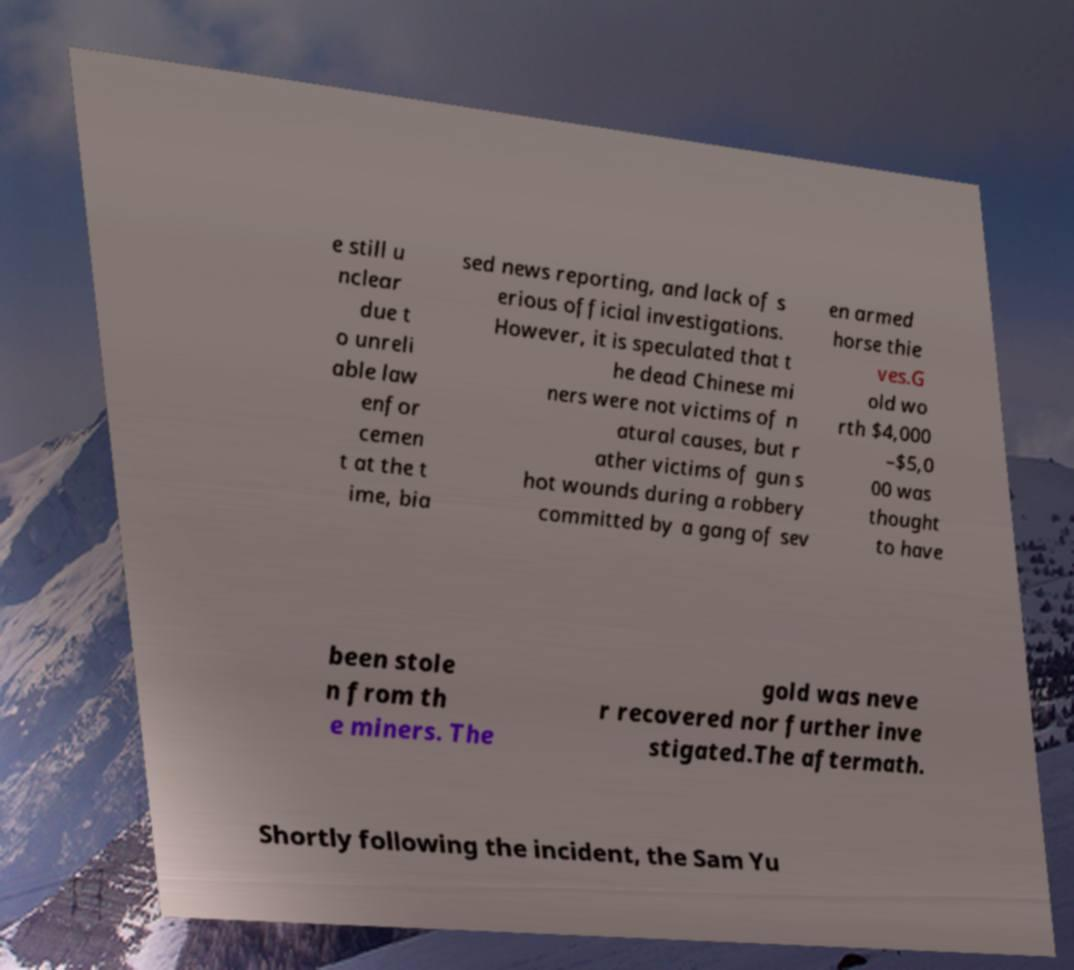Please read and relay the text visible in this image. What does it say? e still u nclear due t o unreli able law enfor cemen t at the t ime, bia sed news reporting, and lack of s erious official investigations. However, it is speculated that t he dead Chinese mi ners were not victims of n atural causes, but r ather victims of gun s hot wounds during a robbery committed by a gang of sev en armed horse thie ves.G old wo rth $4,000 –$5,0 00 was thought to have been stole n from th e miners. The gold was neve r recovered nor further inve stigated.The aftermath. Shortly following the incident, the Sam Yu 